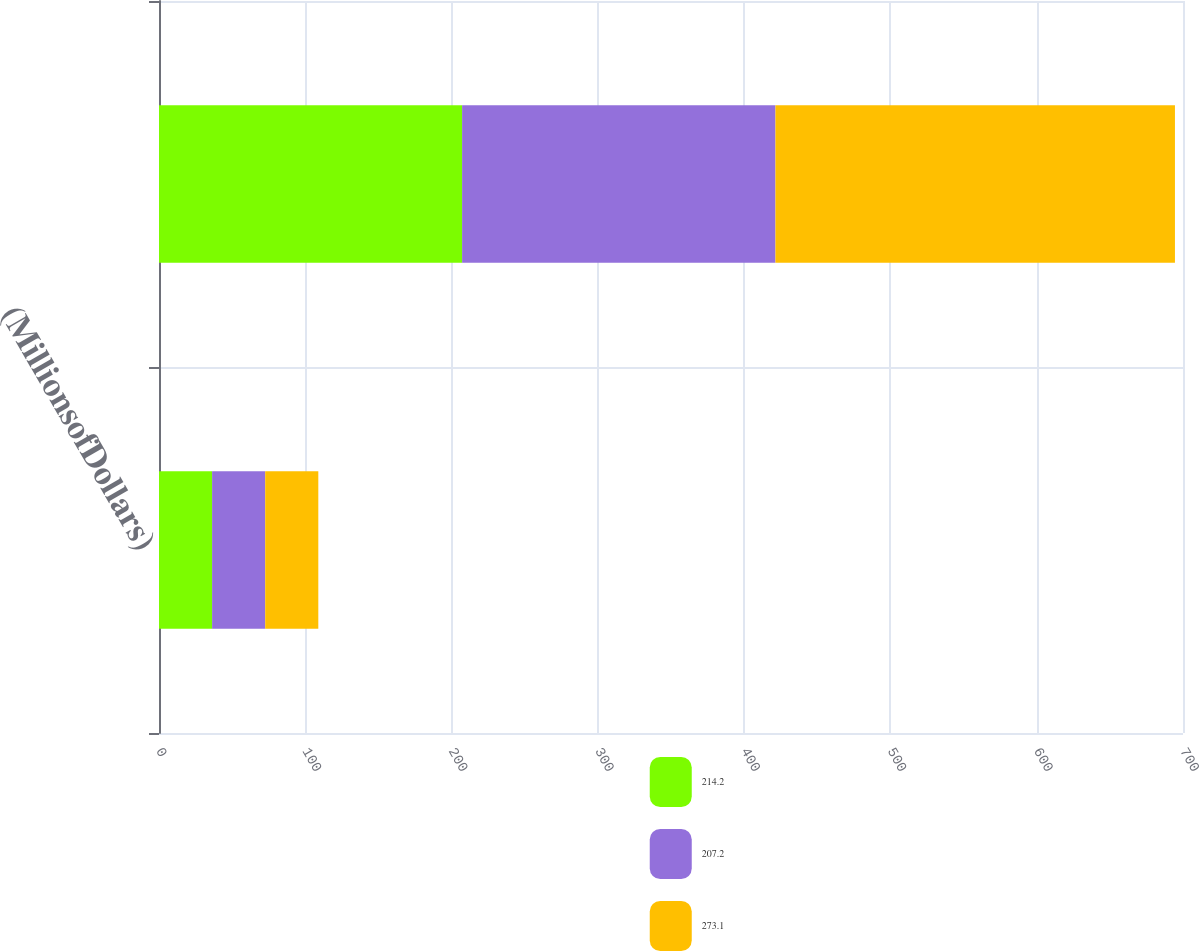<chart> <loc_0><loc_0><loc_500><loc_500><stacked_bar_chart><ecel><fcel>(MillionsofDollars)<fcel>Unnamed: 2<nl><fcel>214.2<fcel>36.3<fcel>207.2<nl><fcel>207.2<fcel>36.3<fcel>214.2<nl><fcel>273.1<fcel>36.3<fcel>273.1<nl></chart> 